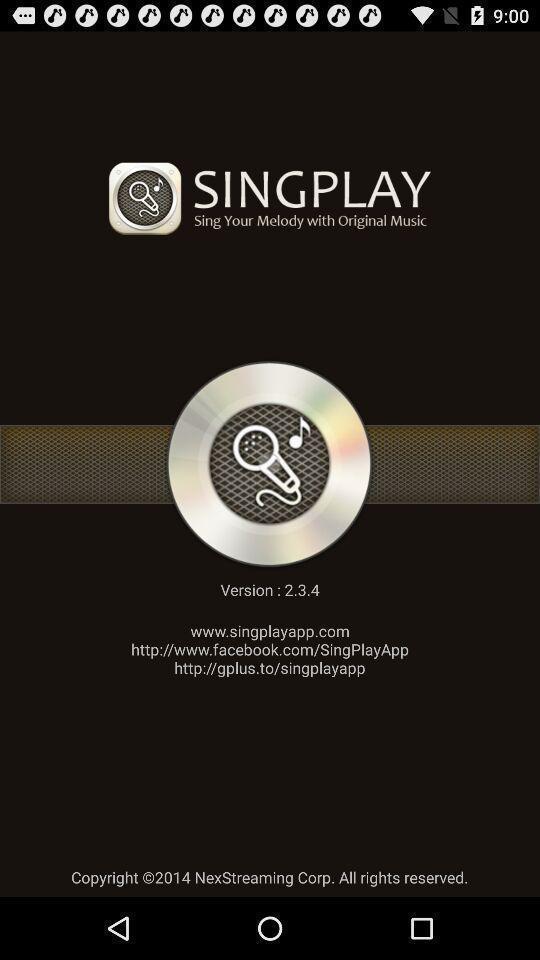Summarize the information in this screenshot. Screen asking to update to it 's latest version. 